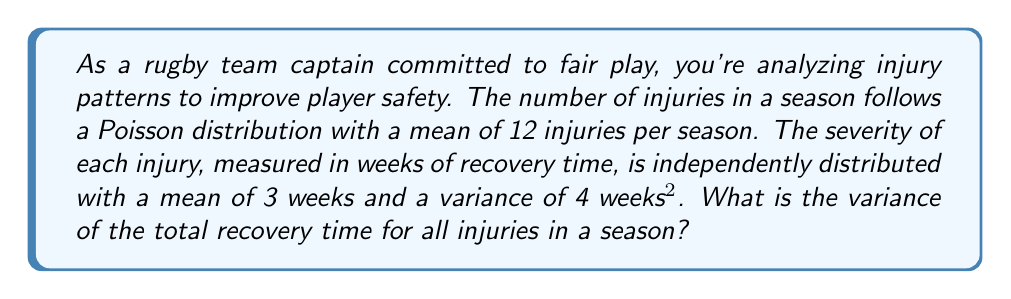What is the answer to this math problem? Let's approach this step-by-step using the compound Poisson process:

1) Let $N$ be the number of injuries in a season (Poisson distributed)
   $E[N] = \lambda = 12$

2) Let $X_i$ be the recovery time for the $i$-th injury
   $E[X_i] = \mu = 3$ weeks
   $Var(X_i) = \sigma^2 = 4$ weeks²

3) The total recovery time $S$ is given by:
   $S = X_1 + X_2 + ... + X_N$

4) For a compound Poisson process, we can use the formula:
   $Var(S) = E[N]E[X^2] = \lambda(E[X]^2 + Var(X))$

5) Calculate $E[X]^2$:
   $E[X]^2 = \mu^2 = 3^2 = 9$

6) Substitute into the formula:
   $Var(S) = \lambda(\mu^2 + \sigma^2)$
   $Var(S) = 12(9 + 4)$
   $Var(S) = 12(13)$
   $Var(S) = 156$

Therefore, the variance of the total recovery time for all injuries in a season is 156 weeks².
Answer: 156 weeks² 